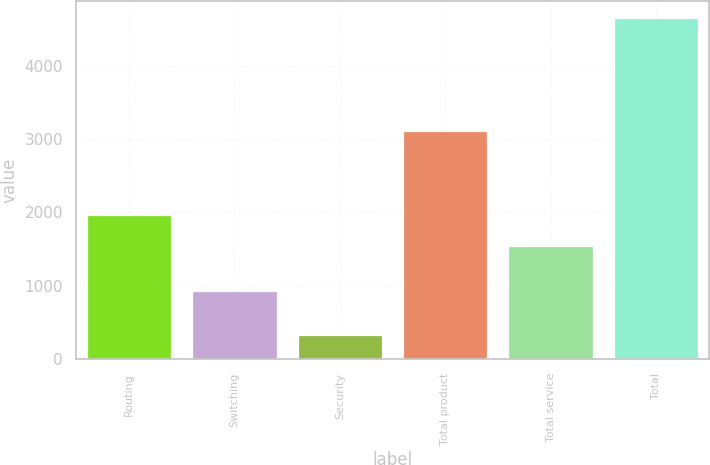Convert chart. <chart><loc_0><loc_0><loc_500><loc_500><bar_chart><fcel>Routing<fcel>Switching<fcel>Security<fcel>Total product<fcel>Total service<fcel>Total<nl><fcel>1971.85<fcel>934.4<fcel>333<fcel>3107.1<fcel>1540.4<fcel>4647.5<nl></chart> 